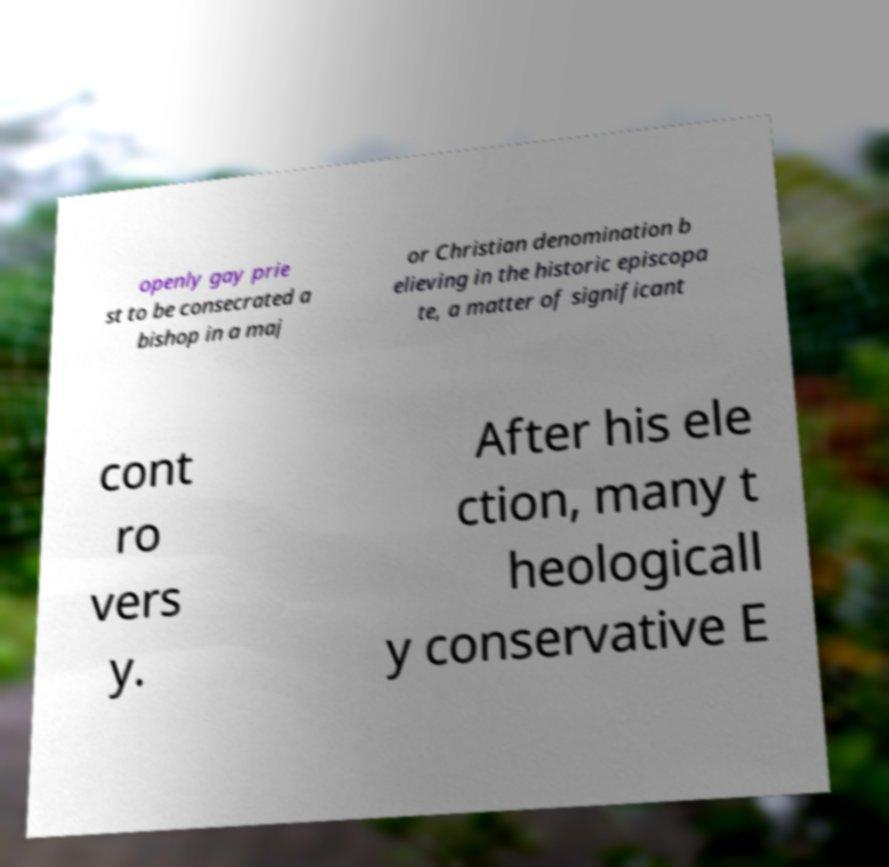Could you assist in decoding the text presented in this image and type it out clearly? openly gay prie st to be consecrated a bishop in a maj or Christian denomination b elieving in the historic episcopa te, a matter of significant cont ro vers y. After his ele ction, many t heologicall y conservative E 